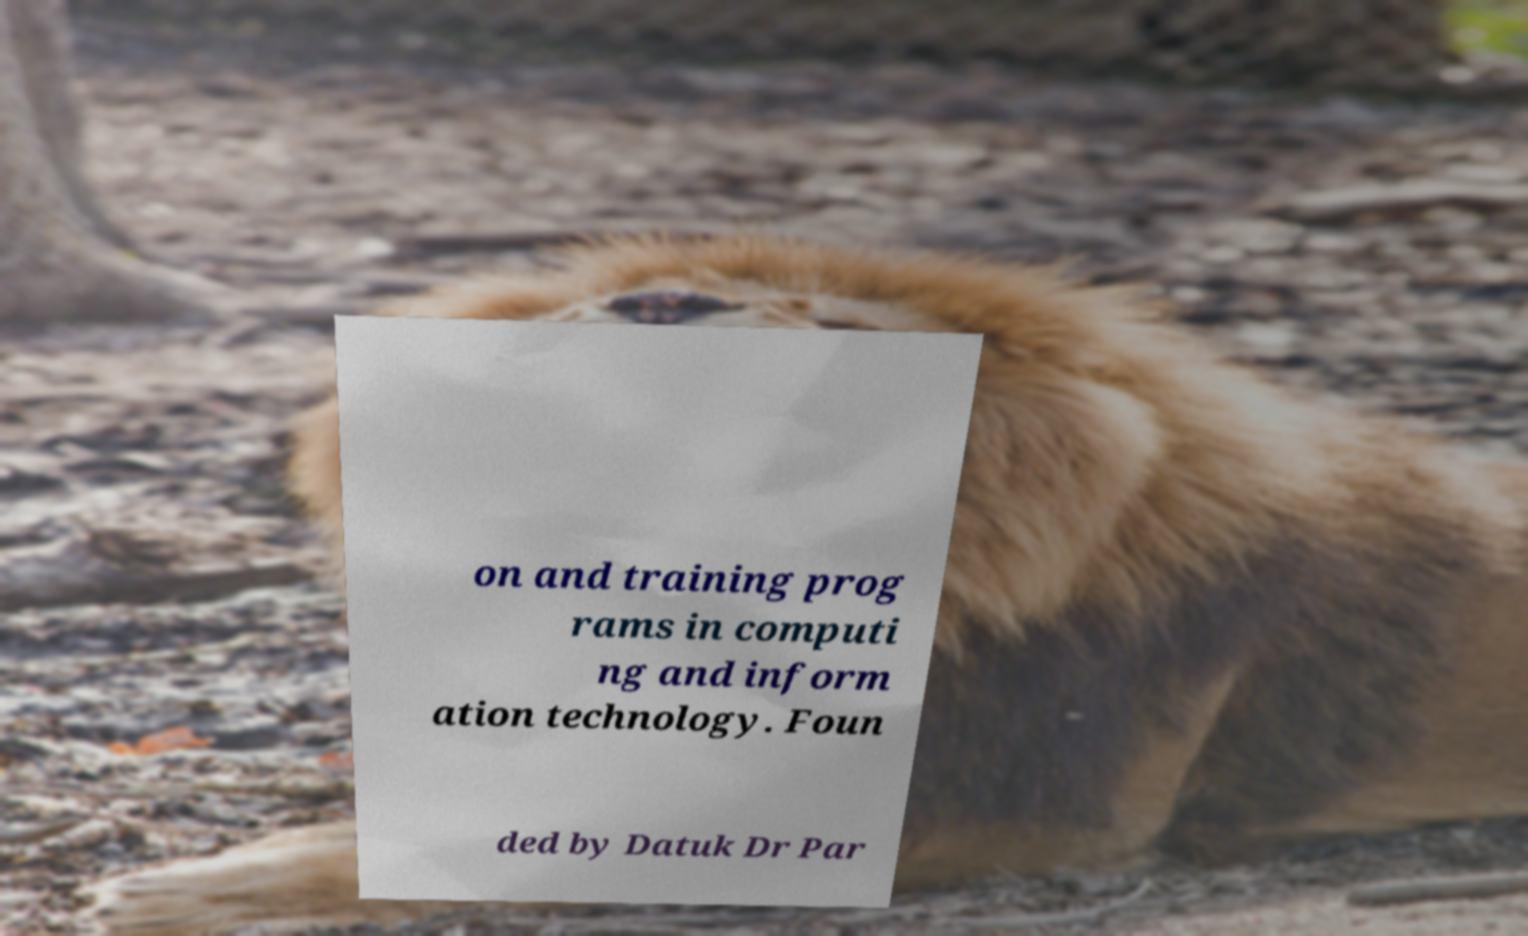There's text embedded in this image that I need extracted. Can you transcribe it verbatim? on and training prog rams in computi ng and inform ation technology. Foun ded by Datuk Dr Par 